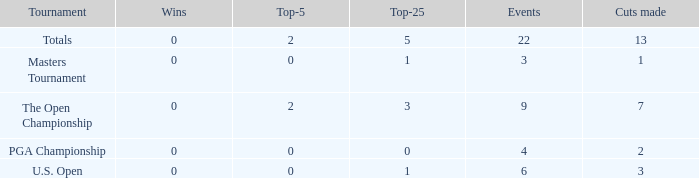What is the total number of wins for events with under 2 top-5s, under 5 top-25s, and more than 4 events played? 1.0. 